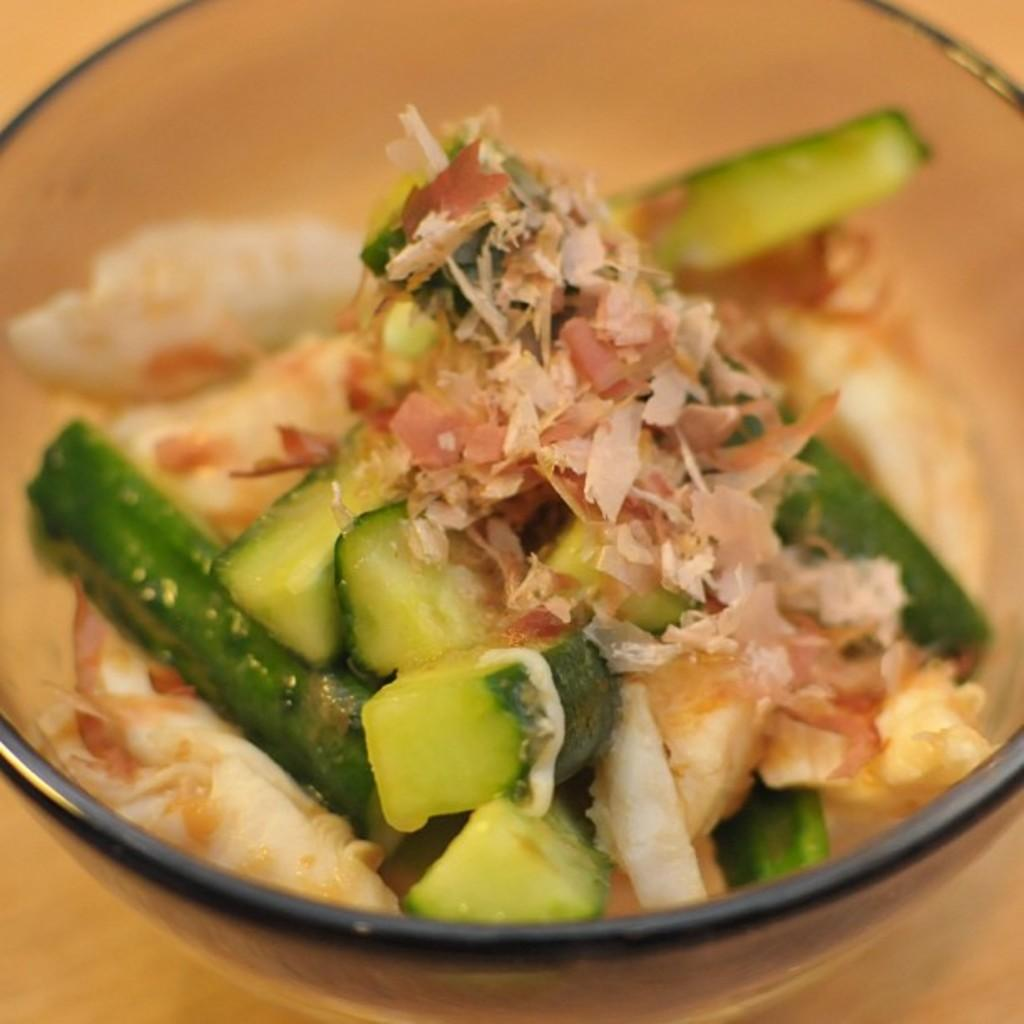What is in the bowl that is visible in the image? There are food items in a bowl in the image. Where is the bowl located in the image? The bowl is placed on top of a table in the image. What type of ornament is hanging from the ceiling above the table in the image? There is no ornament hanging from the ceiling above the table in the image. 